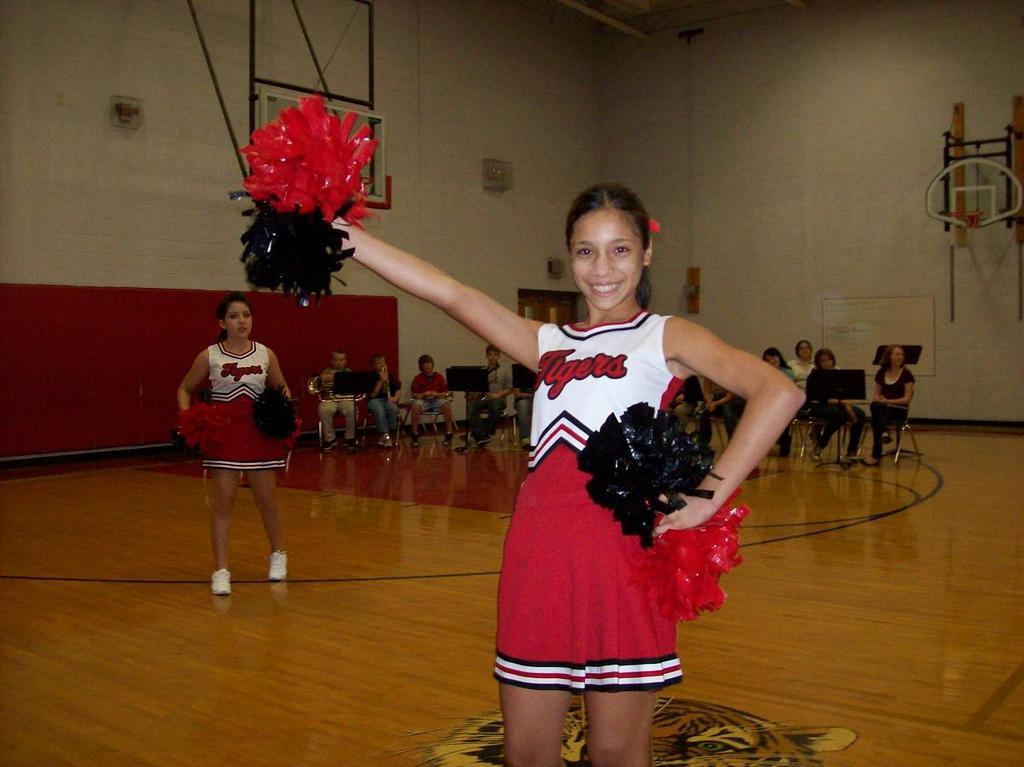<image>
Write a terse but informative summary of the picture. A cheerleader who has a Tigers emblem on her outfit is smiling. 